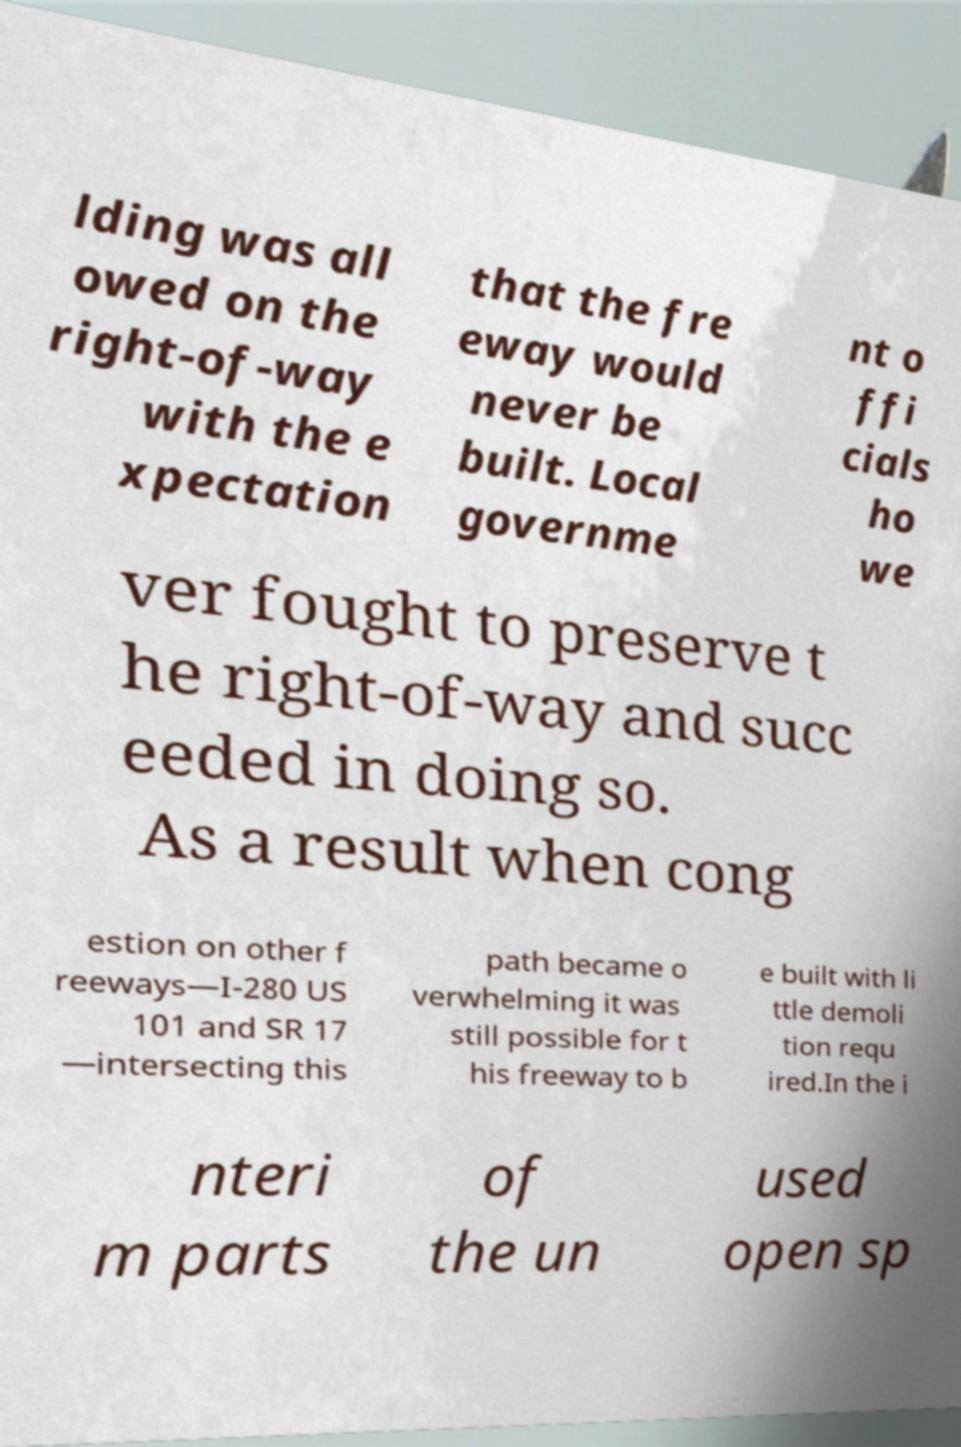Please read and relay the text visible in this image. What does it say? lding was all owed on the right-of-way with the e xpectation that the fre eway would never be built. Local governme nt o ffi cials ho we ver fought to preserve t he right-of-way and succ eeded in doing so. As a result when cong estion on other f reeways—I-280 US 101 and SR 17 —intersecting this path became o verwhelming it was still possible for t his freeway to b e built with li ttle demoli tion requ ired.In the i nteri m parts of the un used open sp 